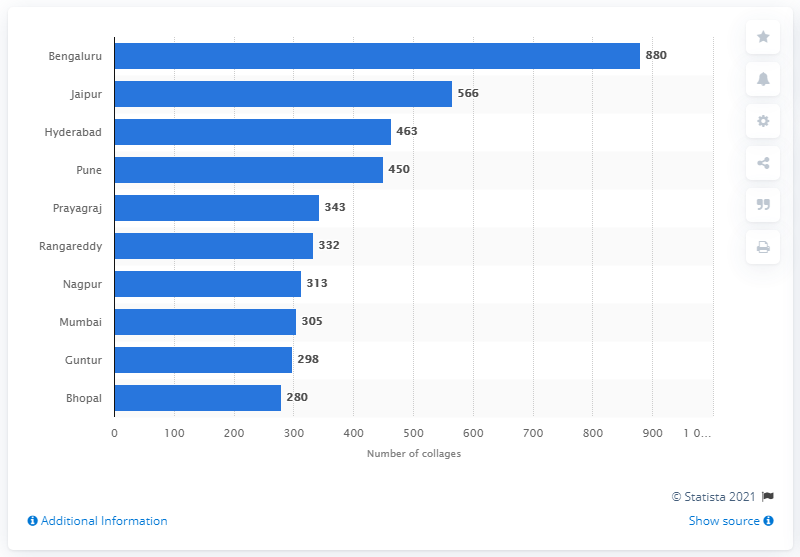Point out several critical features in this image. In 2019, the city of Bengaluru had a total of 880 colleges. The capital of Rajasthan is Jaipur. 